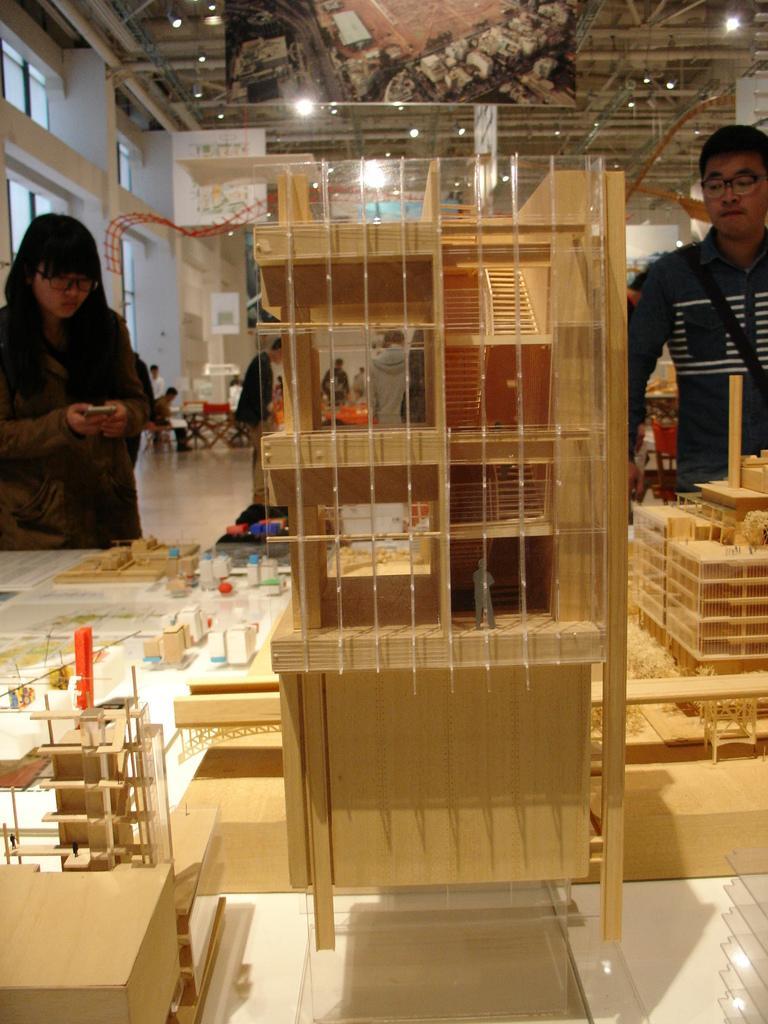How would you summarize this image in a sentence or two? Here in this picture we can see some wooden building designs present on a table and we can also see people standing on the floor and watching it and at the top we can see lights present and in the far we can see people sitting on chairs with table in front of them. 